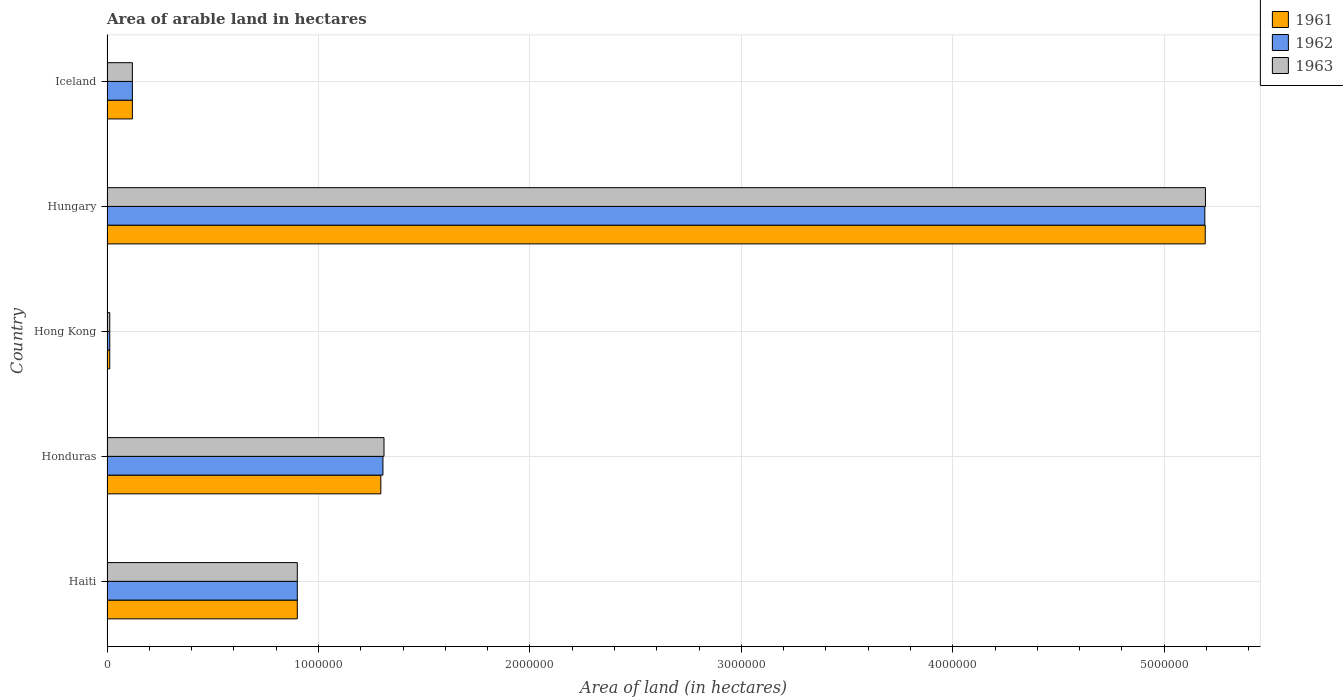How many different coloured bars are there?
Your answer should be compact. 3. How many groups of bars are there?
Make the answer very short. 5. Are the number of bars per tick equal to the number of legend labels?
Your response must be concise. Yes. Are the number of bars on each tick of the Y-axis equal?
Make the answer very short. Yes. How many bars are there on the 3rd tick from the bottom?
Your response must be concise. 3. What is the label of the 2nd group of bars from the top?
Provide a short and direct response. Hungary. Across all countries, what is the maximum total arable land in 1962?
Offer a very short reply. 5.19e+06. Across all countries, what is the minimum total arable land in 1962?
Your response must be concise. 1.30e+04. In which country was the total arable land in 1961 maximum?
Your answer should be compact. Hungary. In which country was the total arable land in 1963 minimum?
Offer a terse response. Hong Kong. What is the total total arable land in 1963 in the graph?
Make the answer very short. 7.54e+06. What is the difference between the total arable land in 1961 in Haiti and that in Honduras?
Your answer should be compact. -3.95e+05. What is the difference between the total arable land in 1962 in Honduras and the total arable land in 1961 in Hungary?
Make the answer very short. -3.89e+06. What is the average total arable land in 1961 per country?
Provide a short and direct response. 1.50e+06. What is the difference between the total arable land in 1962 and total arable land in 1961 in Iceland?
Offer a terse response. 0. What is the ratio of the total arable land in 1962 in Hong Kong to that in Hungary?
Your answer should be compact. 0. Is the total arable land in 1963 in Hong Kong less than that in Hungary?
Your answer should be compact. Yes. Is the difference between the total arable land in 1962 in Hong Kong and Hungary greater than the difference between the total arable land in 1961 in Hong Kong and Hungary?
Offer a terse response. Yes. What is the difference between the highest and the second highest total arable land in 1961?
Your response must be concise. 3.90e+06. What is the difference between the highest and the lowest total arable land in 1962?
Ensure brevity in your answer.  5.18e+06. In how many countries, is the total arable land in 1963 greater than the average total arable land in 1963 taken over all countries?
Provide a short and direct response. 1. What does the 2nd bar from the bottom in Iceland represents?
Keep it short and to the point. 1962. Are all the bars in the graph horizontal?
Give a very brief answer. Yes. What is the difference between two consecutive major ticks on the X-axis?
Make the answer very short. 1.00e+06. Are the values on the major ticks of X-axis written in scientific E-notation?
Keep it short and to the point. No. How are the legend labels stacked?
Offer a terse response. Vertical. What is the title of the graph?
Your answer should be compact. Area of arable land in hectares. What is the label or title of the X-axis?
Provide a short and direct response. Area of land (in hectares). What is the label or title of the Y-axis?
Provide a succinct answer. Country. What is the Area of land (in hectares) in 1961 in Haiti?
Keep it short and to the point. 9.00e+05. What is the Area of land (in hectares) in 1962 in Haiti?
Your answer should be very brief. 9.00e+05. What is the Area of land (in hectares) in 1961 in Honduras?
Provide a short and direct response. 1.30e+06. What is the Area of land (in hectares) of 1962 in Honduras?
Offer a very short reply. 1.30e+06. What is the Area of land (in hectares) in 1963 in Honduras?
Your answer should be very brief. 1.31e+06. What is the Area of land (in hectares) in 1961 in Hong Kong?
Ensure brevity in your answer.  1.30e+04. What is the Area of land (in hectares) of 1962 in Hong Kong?
Give a very brief answer. 1.30e+04. What is the Area of land (in hectares) in 1963 in Hong Kong?
Offer a terse response. 1.30e+04. What is the Area of land (in hectares) of 1961 in Hungary?
Offer a very short reply. 5.19e+06. What is the Area of land (in hectares) in 1962 in Hungary?
Give a very brief answer. 5.19e+06. What is the Area of land (in hectares) in 1963 in Hungary?
Give a very brief answer. 5.20e+06. What is the Area of land (in hectares) in 1962 in Iceland?
Offer a terse response. 1.20e+05. Across all countries, what is the maximum Area of land (in hectares) in 1961?
Provide a short and direct response. 5.19e+06. Across all countries, what is the maximum Area of land (in hectares) of 1962?
Provide a short and direct response. 5.19e+06. Across all countries, what is the maximum Area of land (in hectares) in 1963?
Your response must be concise. 5.20e+06. Across all countries, what is the minimum Area of land (in hectares) of 1961?
Your response must be concise. 1.30e+04. Across all countries, what is the minimum Area of land (in hectares) of 1962?
Provide a succinct answer. 1.30e+04. Across all countries, what is the minimum Area of land (in hectares) in 1963?
Make the answer very short. 1.30e+04. What is the total Area of land (in hectares) of 1961 in the graph?
Keep it short and to the point. 7.52e+06. What is the total Area of land (in hectares) in 1962 in the graph?
Make the answer very short. 7.53e+06. What is the total Area of land (in hectares) of 1963 in the graph?
Make the answer very short. 7.54e+06. What is the difference between the Area of land (in hectares) in 1961 in Haiti and that in Honduras?
Your response must be concise. -3.95e+05. What is the difference between the Area of land (in hectares) in 1962 in Haiti and that in Honduras?
Provide a succinct answer. -4.05e+05. What is the difference between the Area of land (in hectares) of 1963 in Haiti and that in Honduras?
Ensure brevity in your answer.  -4.10e+05. What is the difference between the Area of land (in hectares) in 1961 in Haiti and that in Hong Kong?
Provide a succinct answer. 8.87e+05. What is the difference between the Area of land (in hectares) of 1962 in Haiti and that in Hong Kong?
Provide a succinct answer. 8.87e+05. What is the difference between the Area of land (in hectares) of 1963 in Haiti and that in Hong Kong?
Your answer should be very brief. 8.87e+05. What is the difference between the Area of land (in hectares) of 1961 in Haiti and that in Hungary?
Keep it short and to the point. -4.29e+06. What is the difference between the Area of land (in hectares) in 1962 in Haiti and that in Hungary?
Provide a succinct answer. -4.29e+06. What is the difference between the Area of land (in hectares) in 1963 in Haiti and that in Hungary?
Your answer should be compact. -4.30e+06. What is the difference between the Area of land (in hectares) in 1961 in Haiti and that in Iceland?
Provide a short and direct response. 7.80e+05. What is the difference between the Area of land (in hectares) of 1962 in Haiti and that in Iceland?
Make the answer very short. 7.80e+05. What is the difference between the Area of land (in hectares) in 1963 in Haiti and that in Iceland?
Your response must be concise. 7.80e+05. What is the difference between the Area of land (in hectares) in 1961 in Honduras and that in Hong Kong?
Keep it short and to the point. 1.28e+06. What is the difference between the Area of land (in hectares) of 1962 in Honduras and that in Hong Kong?
Your answer should be very brief. 1.29e+06. What is the difference between the Area of land (in hectares) in 1963 in Honduras and that in Hong Kong?
Provide a short and direct response. 1.30e+06. What is the difference between the Area of land (in hectares) in 1961 in Honduras and that in Hungary?
Provide a short and direct response. -3.90e+06. What is the difference between the Area of land (in hectares) of 1962 in Honduras and that in Hungary?
Provide a succinct answer. -3.89e+06. What is the difference between the Area of land (in hectares) of 1963 in Honduras and that in Hungary?
Provide a short and direct response. -3.88e+06. What is the difference between the Area of land (in hectares) of 1961 in Honduras and that in Iceland?
Your answer should be compact. 1.18e+06. What is the difference between the Area of land (in hectares) in 1962 in Honduras and that in Iceland?
Keep it short and to the point. 1.18e+06. What is the difference between the Area of land (in hectares) of 1963 in Honduras and that in Iceland?
Offer a very short reply. 1.19e+06. What is the difference between the Area of land (in hectares) in 1961 in Hong Kong and that in Hungary?
Keep it short and to the point. -5.18e+06. What is the difference between the Area of land (in hectares) in 1962 in Hong Kong and that in Hungary?
Make the answer very short. -5.18e+06. What is the difference between the Area of land (in hectares) in 1963 in Hong Kong and that in Hungary?
Offer a terse response. -5.18e+06. What is the difference between the Area of land (in hectares) of 1961 in Hong Kong and that in Iceland?
Your response must be concise. -1.07e+05. What is the difference between the Area of land (in hectares) in 1962 in Hong Kong and that in Iceland?
Offer a very short reply. -1.07e+05. What is the difference between the Area of land (in hectares) of 1963 in Hong Kong and that in Iceland?
Provide a succinct answer. -1.07e+05. What is the difference between the Area of land (in hectares) of 1961 in Hungary and that in Iceland?
Provide a short and direct response. 5.07e+06. What is the difference between the Area of land (in hectares) in 1962 in Hungary and that in Iceland?
Make the answer very short. 5.07e+06. What is the difference between the Area of land (in hectares) in 1963 in Hungary and that in Iceland?
Provide a succinct answer. 5.08e+06. What is the difference between the Area of land (in hectares) in 1961 in Haiti and the Area of land (in hectares) in 1962 in Honduras?
Give a very brief answer. -4.05e+05. What is the difference between the Area of land (in hectares) in 1961 in Haiti and the Area of land (in hectares) in 1963 in Honduras?
Keep it short and to the point. -4.10e+05. What is the difference between the Area of land (in hectares) in 1962 in Haiti and the Area of land (in hectares) in 1963 in Honduras?
Provide a succinct answer. -4.10e+05. What is the difference between the Area of land (in hectares) of 1961 in Haiti and the Area of land (in hectares) of 1962 in Hong Kong?
Your response must be concise. 8.87e+05. What is the difference between the Area of land (in hectares) of 1961 in Haiti and the Area of land (in hectares) of 1963 in Hong Kong?
Your answer should be very brief. 8.87e+05. What is the difference between the Area of land (in hectares) in 1962 in Haiti and the Area of land (in hectares) in 1963 in Hong Kong?
Your response must be concise. 8.87e+05. What is the difference between the Area of land (in hectares) in 1961 in Haiti and the Area of land (in hectares) in 1962 in Hungary?
Your answer should be compact. -4.29e+06. What is the difference between the Area of land (in hectares) in 1961 in Haiti and the Area of land (in hectares) in 1963 in Hungary?
Offer a very short reply. -4.30e+06. What is the difference between the Area of land (in hectares) in 1962 in Haiti and the Area of land (in hectares) in 1963 in Hungary?
Offer a very short reply. -4.30e+06. What is the difference between the Area of land (in hectares) of 1961 in Haiti and the Area of land (in hectares) of 1962 in Iceland?
Offer a very short reply. 7.80e+05. What is the difference between the Area of land (in hectares) of 1961 in Haiti and the Area of land (in hectares) of 1963 in Iceland?
Provide a succinct answer. 7.80e+05. What is the difference between the Area of land (in hectares) of 1962 in Haiti and the Area of land (in hectares) of 1963 in Iceland?
Provide a short and direct response. 7.80e+05. What is the difference between the Area of land (in hectares) of 1961 in Honduras and the Area of land (in hectares) of 1962 in Hong Kong?
Make the answer very short. 1.28e+06. What is the difference between the Area of land (in hectares) in 1961 in Honduras and the Area of land (in hectares) in 1963 in Hong Kong?
Give a very brief answer. 1.28e+06. What is the difference between the Area of land (in hectares) of 1962 in Honduras and the Area of land (in hectares) of 1963 in Hong Kong?
Make the answer very short. 1.29e+06. What is the difference between the Area of land (in hectares) in 1961 in Honduras and the Area of land (in hectares) in 1962 in Hungary?
Offer a very short reply. -3.90e+06. What is the difference between the Area of land (in hectares) of 1961 in Honduras and the Area of land (in hectares) of 1963 in Hungary?
Ensure brevity in your answer.  -3.90e+06. What is the difference between the Area of land (in hectares) of 1962 in Honduras and the Area of land (in hectares) of 1963 in Hungary?
Your answer should be compact. -3.89e+06. What is the difference between the Area of land (in hectares) of 1961 in Honduras and the Area of land (in hectares) of 1962 in Iceland?
Ensure brevity in your answer.  1.18e+06. What is the difference between the Area of land (in hectares) in 1961 in Honduras and the Area of land (in hectares) in 1963 in Iceland?
Give a very brief answer. 1.18e+06. What is the difference between the Area of land (in hectares) in 1962 in Honduras and the Area of land (in hectares) in 1963 in Iceland?
Your answer should be very brief. 1.18e+06. What is the difference between the Area of land (in hectares) of 1961 in Hong Kong and the Area of land (in hectares) of 1962 in Hungary?
Make the answer very short. -5.18e+06. What is the difference between the Area of land (in hectares) of 1961 in Hong Kong and the Area of land (in hectares) of 1963 in Hungary?
Provide a succinct answer. -5.18e+06. What is the difference between the Area of land (in hectares) of 1962 in Hong Kong and the Area of land (in hectares) of 1963 in Hungary?
Provide a short and direct response. -5.18e+06. What is the difference between the Area of land (in hectares) of 1961 in Hong Kong and the Area of land (in hectares) of 1962 in Iceland?
Your answer should be very brief. -1.07e+05. What is the difference between the Area of land (in hectares) in 1961 in Hong Kong and the Area of land (in hectares) in 1963 in Iceland?
Provide a short and direct response. -1.07e+05. What is the difference between the Area of land (in hectares) of 1962 in Hong Kong and the Area of land (in hectares) of 1963 in Iceland?
Ensure brevity in your answer.  -1.07e+05. What is the difference between the Area of land (in hectares) in 1961 in Hungary and the Area of land (in hectares) in 1962 in Iceland?
Your answer should be compact. 5.07e+06. What is the difference between the Area of land (in hectares) of 1961 in Hungary and the Area of land (in hectares) of 1963 in Iceland?
Offer a terse response. 5.07e+06. What is the difference between the Area of land (in hectares) in 1962 in Hungary and the Area of land (in hectares) in 1963 in Iceland?
Your answer should be very brief. 5.07e+06. What is the average Area of land (in hectares) in 1961 per country?
Offer a terse response. 1.50e+06. What is the average Area of land (in hectares) in 1962 per country?
Your answer should be compact. 1.51e+06. What is the average Area of land (in hectares) in 1963 per country?
Offer a very short reply. 1.51e+06. What is the difference between the Area of land (in hectares) in 1961 and Area of land (in hectares) in 1962 in Haiti?
Keep it short and to the point. 0. What is the difference between the Area of land (in hectares) in 1961 and Area of land (in hectares) in 1963 in Haiti?
Give a very brief answer. 0. What is the difference between the Area of land (in hectares) of 1961 and Area of land (in hectares) of 1963 in Honduras?
Keep it short and to the point. -1.50e+04. What is the difference between the Area of land (in hectares) of 1962 and Area of land (in hectares) of 1963 in Honduras?
Provide a succinct answer. -5000. What is the difference between the Area of land (in hectares) of 1961 and Area of land (in hectares) of 1962 in Hong Kong?
Make the answer very short. 0. What is the difference between the Area of land (in hectares) of 1961 and Area of land (in hectares) of 1963 in Hong Kong?
Offer a terse response. 0. What is the difference between the Area of land (in hectares) in 1962 and Area of land (in hectares) in 1963 in Hong Kong?
Offer a very short reply. 0. What is the difference between the Area of land (in hectares) of 1961 and Area of land (in hectares) of 1963 in Hungary?
Keep it short and to the point. -1000. What is the difference between the Area of land (in hectares) in 1962 and Area of land (in hectares) in 1963 in Hungary?
Offer a very short reply. -3000. What is the difference between the Area of land (in hectares) of 1961 and Area of land (in hectares) of 1963 in Iceland?
Offer a very short reply. 0. What is the ratio of the Area of land (in hectares) in 1961 in Haiti to that in Honduras?
Give a very brief answer. 0.69. What is the ratio of the Area of land (in hectares) in 1962 in Haiti to that in Honduras?
Your answer should be very brief. 0.69. What is the ratio of the Area of land (in hectares) in 1963 in Haiti to that in Honduras?
Your response must be concise. 0.69. What is the ratio of the Area of land (in hectares) in 1961 in Haiti to that in Hong Kong?
Give a very brief answer. 69.23. What is the ratio of the Area of land (in hectares) in 1962 in Haiti to that in Hong Kong?
Offer a very short reply. 69.23. What is the ratio of the Area of land (in hectares) of 1963 in Haiti to that in Hong Kong?
Offer a terse response. 69.23. What is the ratio of the Area of land (in hectares) in 1961 in Haiti to that in Hungary?
Offer a very short reply. 0.17. What is the ratio of the Area of land (in hectares) in 1962 in Haiti to that in Hungary?
Ensure brevity in your answer.  0.17. What is the ratio of the Area of land (in hectares) in 1963 in Haiti to that in Hungary?
Ensure brevity in your answer.  0.17. What is the ratio of the Area of land (in hectares) in 1961 in Haiti to that in Iceland?
Your response must be concise. 7.5. What is the ratio of the Area of land (in hectares) in 1962 in Haiti to that in Iceland?
Give a very brief answer. 7.5. What is the ratio of the Area of land (in hectares) of 1963 in Haiti to that in Iceland?
Offer a terse response. 7.5. What is the ratio of the Area of land (in hectares) in 1961 in Honduras to that in Hong Kong?
Offer a terse response. 99.62. What is the ratio of the Area of land (in hectares) of 1962 in Honduras to that in Hong Kong?
Your answer should be very brief. 100.38. What is the ratio of the Area of land (in hectares) in 1963 in Honduras to that in Hong Kong?
Your answer should be compact. 100.77. What is the ratio of the Area of land (in hectares) of 1961 in Honduras to that in Hungary?
Your response must be concise. 0.25. What is the ratio of the Area of land (in hectares) in 1962 in Honduras to that in Hungary?
Make the answer very short. 0.25. What is the ratio of the Area of land (in hectares) of 1963 in Honduras to that in Hungary?
Provide a short and direct response. 0.25. What is the ratio of the Area of land (in hectares) of 1961 in Honduras to that in Iceland?
Your response must be concise. 10.79. What is the ratio of the Area of land (in hectares) in 1962 in Honduras to that in Iceland?
Offer a very short reply. 10.88. What is the ratio of the Area of land (in hectares) in 1963 in Honduras to that in Iceland?
Offer a terse response. 10.92. What is the ratio of the Area of land (in hectares) of 1961 in Hong Kong to that in Hungary?
Provide a short and direct response. 0. What is the ratio of the Area of land (in hectares) in 1962 in Hong Kong to that in Hungary?
Offer a terse response. 0. What is the ratio of the Area of land (in hectares) of 1963 in Hong Kong to that in Hungary?
Your response must be concise. 0. What is the ratio of the Area of land (in hectares) of 1961 in Hong Kong to that in Iceland?
Offer a very short reply. 0.11. What is the ratio of the Area of land (in hectares) of 1962 in Hong Kong to that in Iceland?
Offer a terse response. 0.11. What is the ratio of the Area of land (in hectares) of 1963 in Hong Kong to that in Iceland?
Provide a succinct answer. 0.11. What is the ratio of the Area of land (in hectares) in 1961 in Hungary to that in Iceland?
Make the answer very short. 43.28. What is the ratio of the Area of land (in hectares) in 1962 in Hungary to that in Iceland?
Ensure brevity in your answer.  43.27. What is the ratio of the Area of land (in hectares) in 1963 in Hungary to that in Iceland?
Provide a short and direct response. 43.29. What is the difference between the highest and the second highest Area of land (in hectares) of 1961?
Give a very brief answer. 3.90e+06. What is the difference between the highest and the second highest Area of land (in hectares) of 1962?
Make the answer very short. 3.89e+06. What is the difference between the highest and the second highest Area of land (in hectares) in 1963?
Offer a very short reply. 3.88e+06. What is the difference between the highest and the lowest Area of land (in hectares) in 1961?
Make the answer very short. 5.18e+06. What is the difference between the highest and the lowest Area of land (in hectares) in 1962?
Give a very brief answer. 5.18e+06. What is the difference between the highest and the lowest Area of land (in hectares) of 1963?
Your response must be concise. 5.18e+06. 